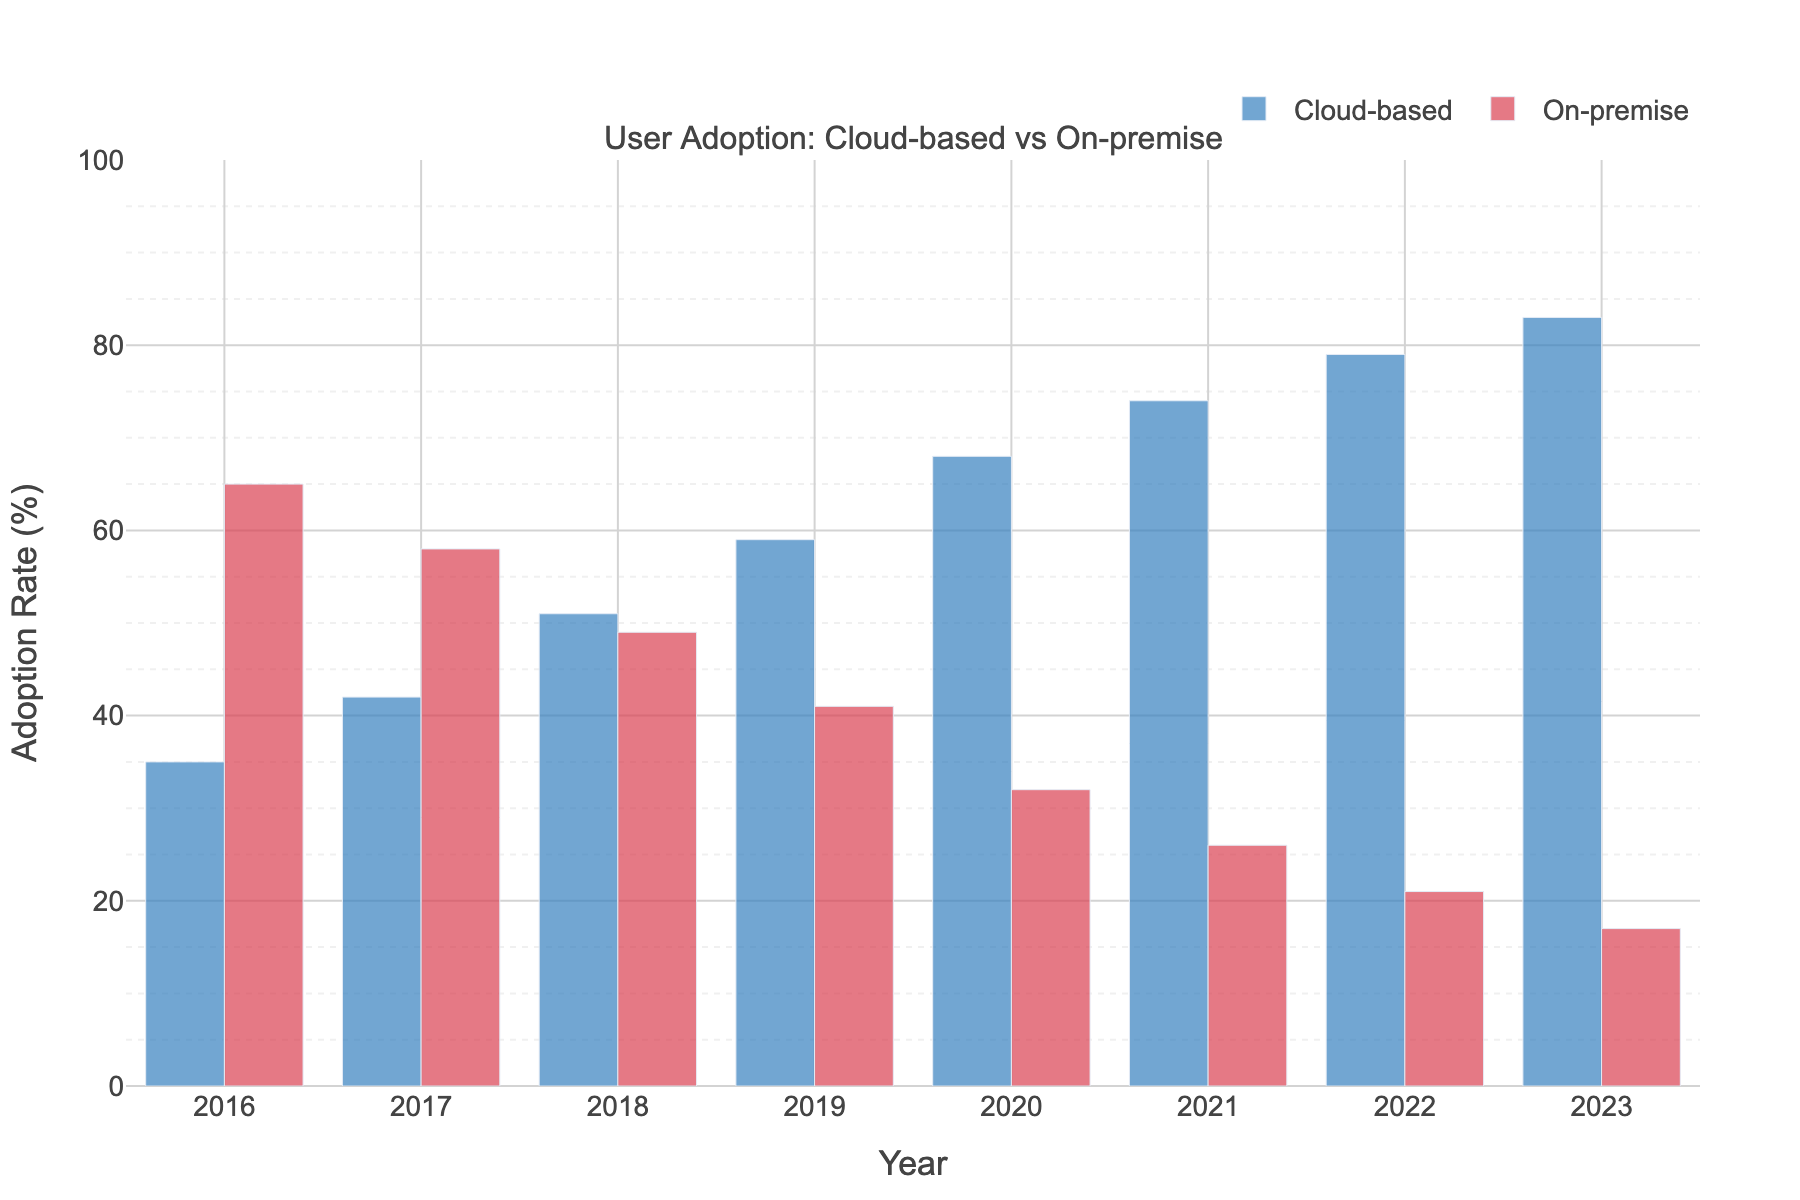What is the user adoption rate for cloud-based solutions in 2023? Look at the bar representing the year 2023 for cloud-based solutions and read off the percentage value.
Answer: 83% Comparison of user adoption rates for cloud-based solutions between 2016 and 2023? Identify the heights of the bars for cloud-based solutions in the years 2016 and 2023 and subtract the 2016 value from the 2023 value.
Answer: 48% What is the total adoption rate percentage for on-premise solutions from 2016 to 2023? Sum the values of on-premise adoption rates for each year from 2016 to 2023.
Answer: 309% By how much did the user adoption rate for on-premise solutions decrease between 2016 and 2023? Identify the heights of the bars for on-premise solutions in the years 2016 and 2023, then subtract the 2023 value from the 2016 value.
Answer: 48% Between which consecutive years did cloud-based solutions see the highest increase in user adoption rate? Calculate the differences in values for cloud-based solutions between each pair of consecutive years and identify the maximum difference. This happened between 2017 and 2018 with an increase from 42% to 51%, a difference of 9%.
Answer: 2017 to 2018 Which year shows equality in user adoption rates for both cloud-based and on-premise solutions? Identify the year where both cloud-based and on-premise solutions have the same adoption rate percentage by visually comparing the heights of their respective bars. This equality occurs in the year 2018 where both show 49%.
Answer: 2018 What is the average adoption rate for cloud-based solutions from 2016 to 2023? Sum the adoption rates for cloud-based solutions for all years from 2016 to 2023, then divide by the number of years (8).
Answer: 61.5% How much did the user adoption rate for cloud-based solutions increase from 2019 to 2020? Identify the values for cloud-based solutions in 2019 and 2020, then subtract the 2019 value from the 2020 value.
Answer: 9% In which year did the on-premise solutions have their highest user adoption rate? Identify the year with the tallest bar for on-premise solutions.
Answer: 2016 What is the difference in user adoption rates between cloud-based and on-premise solutions in 2022? Identify the values for both cloud-based and on-premise solutions in 2022, then subtract the on-premise value from the cloud-based value.
Answer: 58% 